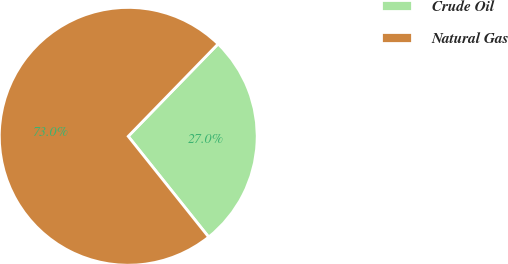<chart> <loc_0><loc_0><loc_500><loc_500><pie_chart><fcel>Crude Oil<fcel>Natural Gas<nl><fcel>27.0%<fcel>73.0%<nl></chart> 